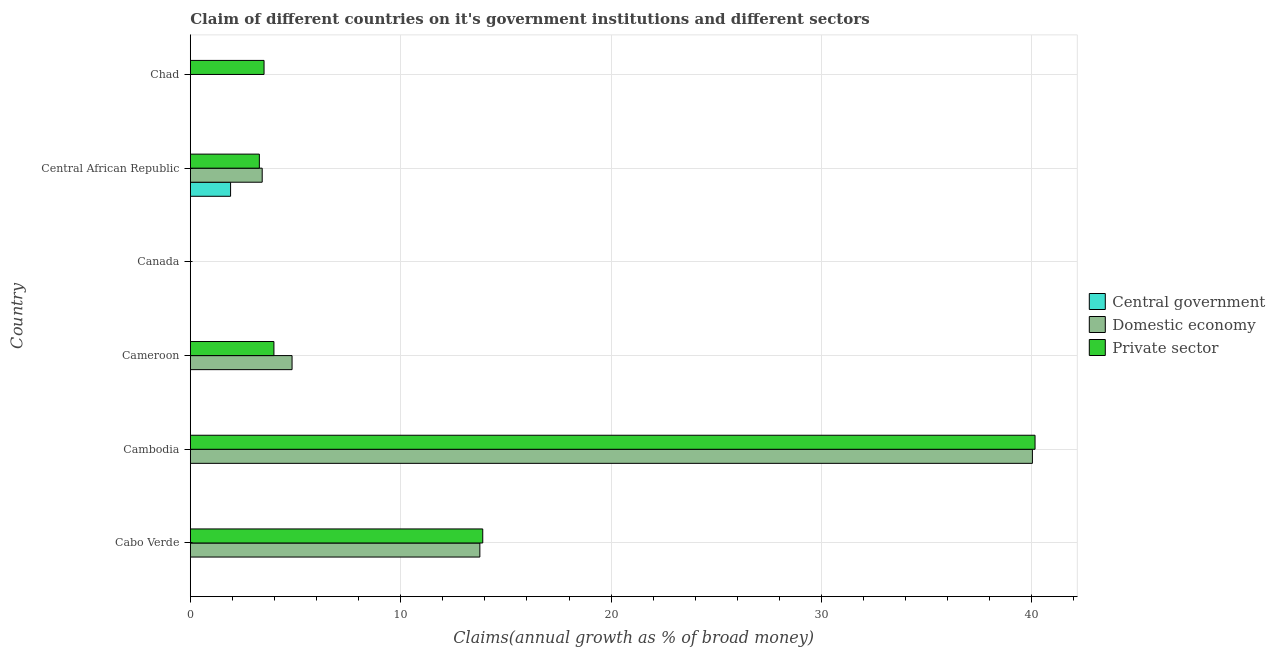What is the label of the 1st group of bars from the top?
Keep it short and to the point. Chad. What is the percentage of claim on the domestic economy in Cambodia?
Make the answer very short. 40.02. Across all countries, what is the maximum percentage of claim on the domestic economy?
Your answer should be very brief. 40.02. In which country was the percentage of claim on the central government maximum?
Offer a very short reply. Central African Republic. What is the total percentage of claim on the central government in the graph?
Provide a short and direct response. 1.91. What is the difference between the percentage of claim on the domestic economy in Cabo Verde and that in Cambodia?
Offer a very short reply. -26.26. What is the difference between the percentage of claim on the domestic economy in Cameroon and the percentage of claim on the central government in Canada?
Make the answer very short. 4.84. What is the average percentage of claim on the private sector per country?
Your answer should be very brief. 10.8. What is the difference between the percentage of claim on the private sector and percentage of claim on the central government in Central African Republic?
Provide a short and direct response. 1.37. Is the percentage of claim on the domestic economy in Cambodia less than that in Cameroon?
Offer a very short reply. No. Is the difference between the percentage of claim on the private sector in Cabo Verde and Cameroon greater than the difference between the percentage of claim on the domestic economy in Cabo Verde and Cameroon?
Give a very brief answer. Yes. What is the difference between the highest and the second highest percentage of claim on the private sector?
Offer a very short reply. 26.25. What is the difference between the highest and the lowest percentage of claim on the central government?
Provide a succinct answer. 1.91. How many bars are there?
Provide a short and direct response. 10. Are all the bars in the graph horizontal?
Ensure brevity in your answer.  Yes. How many countries are there in the graph?
Keep it short and to the point. 6. What is the difference between two consecutive major ticks on the X-axis?
Offer a very short reply. 10. Does the graph contain any zero values?
Your response must be concise. Yes. How are the legend labels stacked?
Make the answer very short. Vertical. What is the title of the graph?
Ensure brevity in your answer.  Claim of different countries on it's government institutions and different sectors. Does "New Zealand" appear as one of the legend labels in the graph?
Make the answer very short. No. What is the label or title of the X-axis?
Your answer should be very brief. Claims(annual growth as % of broad money). What is the Claims(annual growth as % of broad money) of Central government in Cabo Verde?
Make the answer very short. 0. What is the Claims(annual growth as % of broad money) of Domestic economy in Cabo Verde?
Offer a very short reply. 13.76. What is the Claims(annual growth as % of broad money) of Private sector in Cabo Verde?
Your answer should be compact. 13.9. What is the Claims(annual growth as % of broad money) of Central government in Cambodia?
Make the answer very short. 0. What is the Claims(annual growth as % of broad money) in Domestic economy in Cambodia?
Your answer should be very brief. 40.02. What is the Claims(annual growth as % of broad money) of Private sector in Cambodia?
Give a very brief answer. 40.15. What is the Claims(annual growth as % of broad money) in Central government in Cameroon?
Provide a succinct answer. 0. What is the Claims(annual growth as % of broad money) in Domestic economy in Cameroon?
Provide a succinct answer. 4.84. What is the Claims(annual growth as % of broad money) of Private sector in Cameroon?
Your response must be concise. 3.97. What is the Claims(annual growth as % of broad money) of Central government in Canada?
Provide a succinct answer. 0. What is the Claims(annual growth as % of broad money) in Central government in Central African Republic?
Make the answer very short. 1.91. What is the Claims(annual growth as % of broad money) in Domestic economy in Central African Republic?
Provide a short and direct response. 3.42. What is the Claims(annual growth as % of broad money) in Private sector in Central African Republic?
Keep it short and to the point. 3.28. What is the Claims(annual growth as % of broad money) of Domestic economy in Chad?
Provide a succinct answer. 0. What is the Claims(annual growth as % of broad money) in Private sector in Chad?
Ensure brevity in your answer.  3.51. Across all countries, what is the maximum Claims(annual growth as % of broad money) in Central government?
Your answer should be very brief. 1.91. Across all countries, what is the maximum Claims(annual growth as % of broad money) of Domestic economy?
Offer a very short reply. 40.02. Across all countries, what is the maximum Claims(annual growth as % of broad money) of Private sector?
Provide a succinct answer. 40.15. Across all countries, what is the minimum Claims(annual growth as % of broad money) in Central government?
Your answer should be compact. 0. Across all countries, what is the minimum Claims(annual growth as % of broad money) in Private sector?
Keep it short and to the point. 0. What is the total Claims(annual growth as % of broad money) of Central government in the graph?
Give a very brief answer. 1.91. What is the total Claims(annual growth as % of broad money) of Domestic economy in the graph?
Your answer should be compact. 62.04. What is the total Claims(annual growth as % of broad money) in Private sector in the graph?
Offer a terse response. 64.81. What is the difference between the Claims(annual growth as % of broad money) in Domestic economy in Cabo Verde and that in Cambodia?
Offer a very short reply. -26.26. What is the difference between the Claims(annual growth as % of broad money) of Private sector in Cabo Verde and that in Cambodia?
Provide a succinct answer. -26.25. What is the difference between the Claims(annual growth as % of broad money) in Domestic economy in Cabo Verde and that in Cameroon?
Offer a terse response. 8.93. What is the difference between the Claims(annual growth as % of broad money) in Private sector in Cabo Verde and that in Cameroon?
Ensure brevity in your answer.  9.93. What is the difference between the Claims(annual growth as % of broad money) of Domestic economy in Cabo Verde and that in Central African Republic?
Offer a very short reply. 10.35. What is the difference between the Claims(annual growth as % of broad money) in Private sector in Cabo Verde and that in Central African Republic?
Give a very brief answer. 10.62. What is the difference between the Claims(annual growth as % of broad money) of Private sector in Cabo Verde and that in Chad?
Your answer should be very brief. 10.39. What is the difference between the Claims(annual growth as % of broad money) of Domestic economy in Cambodia and that in Cameroon?
Make the answer very short. 35.19. What is the difference between the Claims(annual growth as % of broad money) in Private sector in Cambodia and that in Cameroon?
Keep it short and to the point. 36.18. What is the difference between the Claims(annual growth as % of broad money) in Domestic economy in Cambodia and that in Central African Republic?
Your answer should be compact. 36.61. What is the difference between the Claims(annual growth as % of broad money) of Private sector in Cambodia and that in Central African Republic?
Provide a short and direct response. 36.87. What is the difference between the Claims(annual growth as % of broad money) in Private sector in Cambodia and that in Chad?
Offer a terse response. 36.64. What is the difference between the Claims(annual growth as % of broad money) in Domestic economy in Cameroon and that in Central African Republic?
Offer a very short reply. 1.42. What is the difference between the Claims(annual growth as % of broad money) in Private sector in Cameroon and that in Central African Republic?
Provide a succinct answer. 0.69. What is the difference between the Claims(annual growth as % of broad money) of Private sector in Cameroon and that in Chad?
Your response must be concise. 0.47. What is the difference between the Claims(annual growth as % of broad money) of Private sector in Central African Republic and that in Chad?
Provide a short and direct response. -0.22. What is the difference between the Claims(annual growth as % of broad money) of Domestic economy in Cabo Verde and the Claims(annual growth as % of broad money) of Private sector in Cambodia?
Offer a terse response. -26.39. What is the difference between the Claims(annual growth as % of broad money) of Domestic economy in Cabo Verde and the Claims(annual growth as % of broad money) of Private sector in Cameroon?
Your answer should be very brief. 9.79. What is the difference between the Claims(annual growth as % of broad money) of Domestic economy in Cabo Verde and the Claims(annual growth as % of broad money) of Private sector in Central African Republic?
Your response must be concise. 10.48. What is the difference between the Claims(annual growth as % of broad money) in Domestic economy in Cabo Verde and the Claims(annual growth as % of broad money) in Private sector in Chad?
Ensure brevity in your answer.  10.26. What is the difference between the Claims(annual growth as % of broad money) of Domestic economy in Cambodia and the Claims(annual growth as % of broad money) of Private sector in Cameroon?
Provide a short and direct response. 36.05. What is the difference between the Claims(annual growth as % of broad money) of Domestic economy in Cambodia and the Claims(annual growth as % of broad money) of Private sector in Central African Republic?
Your response must be concise. 36.74. What is the difference between the Claims(annual growth as % of broad money) of Domestic economy in Cambodia and the Claims(annual growth as % of broad money) of Private sector in Chad?
Make the answer very short. 36.52. What is the difference between the Claims(annual growth as % of broad money) in Domestic economy in Cameroon and the Claims(annual growth as % of broad money) in Private sector in Central African Republic?
Your answer should be compact. 1.55. What is the difference between the Claims(annual growth as % of broad money) of Domestic economy in Cameroon and the Claims(annual growth as % of broad money) of Private sector in Chad?
Ensure brevity in your answer.  1.33. What is the difference between the Claims(annual growth as % of broad money) in Central government in Central African Republic and the Claims(annual growth as % of broad money) in Private sector in Chad?
Your answer should be very brief. -1.59. What is the difference between the Claims(annual growth as % of broad money) of Domestic economy in Central African Republic and the Claims(annual growth as % of broad money) of Private sector in Chad?
Provide a short and direct response. -0.09. What is the average Claims(annual growth as % of broad money) in Central government per country?
Keep it short and to the point. 0.32. What is the average Claims(annual growth as % of broad money) of Domestic economy per country?
Your answer should be very brief. 10.34. What is the average Claims(annual growth as % of broad money) of Private sector per country?
Provide a short and direct response. 10.8. What is the difference between the Claims(annual growth as % of broad money) of Domestic economy and Claims(annual growth as % of broad money) of Private sector in Cabo Verde?
Give a very brief answer. -0.14. What is the difference between the Claims(annual growth as % of broad money) in Domestic economy and Claims(annual growth as % of broad money) in Private sector in Cambodia?
Your answer should be very brief. -0.13. What is the difference between the Claims(annual growth as % of broad money) of Domestic economy and Claims(annual growth as % of broad money) of Private sector in Cameroon?
Provide a short and direct response. 0.86. What is the difference between the Claims(annual growth as % of broad money) of Central government and Claims(annual growth as % of broad money) of Domestic economy in Central African Republic?
Your answer should be compact. -1.5. What is the difference between the Claims(annual growth as % of broad money) of Central government and Claims(annual growth as % of broad money) of Private sector in Central African Republic?
Offer a terse response. -1.37. What is the difference between the Claims(annual growth as % of broad money) of Domestic economy and Claims(annual growth as % of broad money) of Private sector in Central African Republic?
Your answer should be very brief. 0.13. What is the ratio of the Claims(annual growth as % of broad money) in Domestic economy in Cabo Verde to that in Cambodia?
Offer a very short reply. 0.34. What is the ratio of the Claims(annual growth as % of broad money) in Private sector in Cabo Verde to that in Cambodia?
Your answer should be compact. 0.35. What is the ratio of the Claims(annual growth as % of broad money) of Domestic economy in Cabo Verde to that in Cameroon?
Provide a short and direct response. 2.85. What is the ratio of the Claims(annual growth as % of broad money) in Private sector in Cabo Verde to that in Cameroon?
Provide a succinct answer. 3.5. What is the ratio of the Claims(annual growth as % of broad money) in Domestic economy in Cabo Verde to that in Central African Republic?
Give a very brief answer. 4.03. What is the ratio of the Claims(annual growth as % of broad money) in Private sector in Cabo Verde to that in Central African Republic?
Your answer should be compact. 4.23. What is the ratio of the Claims(annual growth as % of broad money) of Private sector in Cabo Verde to that in Chad?
Your answer should be very brief. 3.96. What is the ratio of the Claims(annual growth as % of broad money) in Domestic economy in Cambodia to that in Cameroon?
Your response must be concise. 8.27. What is the ratio of the Claims(annual growth as % of broad money) of Private sector in Cambodia to that in Cameroon?
Ensure brevity in your answer.  10.1. What is the ratio of the Claims(annual growth as % of broad money) of Domestic economy in Cambodia to that in Central African Republic?
Ensure brevity in your answer.  11.71. What is the ratio of the Claims(annual growth as % of broad money) of Private sector in Cambodia to that in Central African Republic?
Give a very brief answer. 12.23. What is the ratio of the Claims(annual growth as % of broad money) of Private sector in Cambodia to that in Chad?
Provide a succinct answer. 11.45. What is the ratio of the Claims(annual growth as % of broad money) of Domestic economy in Cameroon to that in Central African Republic?
Ensure brevity in your answer.  1.42. What is the ratio of the Claims(annual growth as % of broad money) in Private sector in Cameroon to that in Central African Republic?
Provide a succinct answer. 1.21. What is the ratio of the Claims(annual growth as % of broad money) in Private sector in Cameroon to that in Chad?
Your answer should be very brief. 1.13. What is the ratio of the Claims(annual growth as % of broad money) of Private sector in Central African Republic to that in Chad?
Make the answer very short. 0.94. What is the difference between the highest and the second highest Claims(annual growth as % of broad money) in Domestic economy?
Offer a very short reply. 26.26. What is the difference between the highest and the second highest Claims(annual growth as % of broad money) in Private sector?
Keep it short and to the point. 26.25. What is the difference between the highest and the lowest Claims(annual growth as % of broad money) in Central government?
Offer a very short reply. 1.91. What is the difference between the highest and the lowest Claims(annual growth as % of broad money) in Domestic economy?
Your answer should be very brief. 40.02. What is the difference between the highest and the lowest Claims(annual growth as % of broad money) in Private sector?
Offer a very short reply. 40.15. 